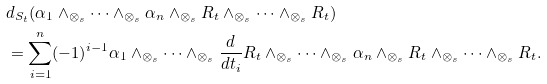<formula> <loc_0><loc_0><loc_500><loc_500>& d _ { S _ { t } } ( \alpha _ { 1 } \wedge _ { \otimes _ { s } } \cdots \wedge _ { \otimes _ { s } } \alpha _ { n } \wedge _ { \otimes _ { s } } R _ { t } \wedge _ { \otimes _ { s } } \cdots \wedge _ { \otimes _ { s } } R _ { t } ) \\ & = \sum ^ { n } _ { i = 1 } ( - 1 ) ^ { i - 1 } \alpha _ { 1 } \wedge _ { \otimes _ { s } } \cdots \wedge _ { \otimes _ { s } } \frac { d } { d t _ { i } } R _ { t } \wedge _ { \otimes _ { s } } \dots \wedge _ { \otimes _ { s } } \alpha _ { n } \wedge _ { \otimes _ { s } } R _ { t } \wedge _ { \otimes _ { s } } \cdots \wedge _ { \otimes _ { s } } R _ { t } .</formula> 